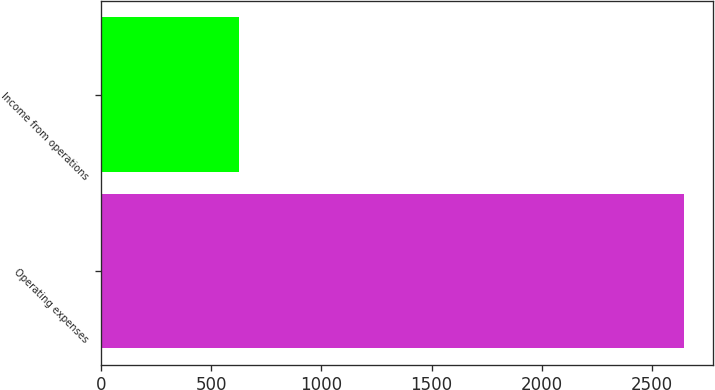Convert chart to OTSL. <chart><loc_0><loc_0><loc_500><loc_500><bar_chart><fcel>Operating expenses<fcel>Income from operations<nl><fcel>2648<fcel>626<nl></chart> 